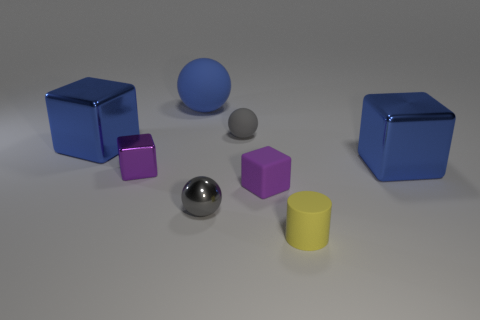There is a blue object that is made of the same material as the small yellow cylinder; what size is it?
Your response must be concise. Large. Is the tiny metallic sphere the same color as the tiny matte ball?
Provide a short and direct response. Yes. Are there more tiny purple matte objects than rubber balls?
Your answer should be compact. No. Is the size of the blue shiny cube that is on the right side of the gray shiny ball the same as the purple thing right of the large matte ball?
Keep it short and to the point. No. There is a sphere that is in front of the large metallic block to the right of the small gray ball that is on the right side of the gray metal object; what color is it?
Keep it short and to the point. Gray. Are there any other blue matte things of the same shape as the blue rubber thing?
Make the answer very short. No. Are there more small purple metallic objects left of the small gray metal thing than large blue rubber cubes?
Your answer should be compact. Yes. How many matte objects are either small purple cylinders or spheres?
Ensure brevity in your answer.  2. There is a block that is behind the purple shiny cube and on the right side of the small purple metal block; what size is it?
Give a very brief answer. Large. There is a small purple metal thing that is left of the cylinder; are there any gray objects behind it?
Keep it short and to the point. Yes. 